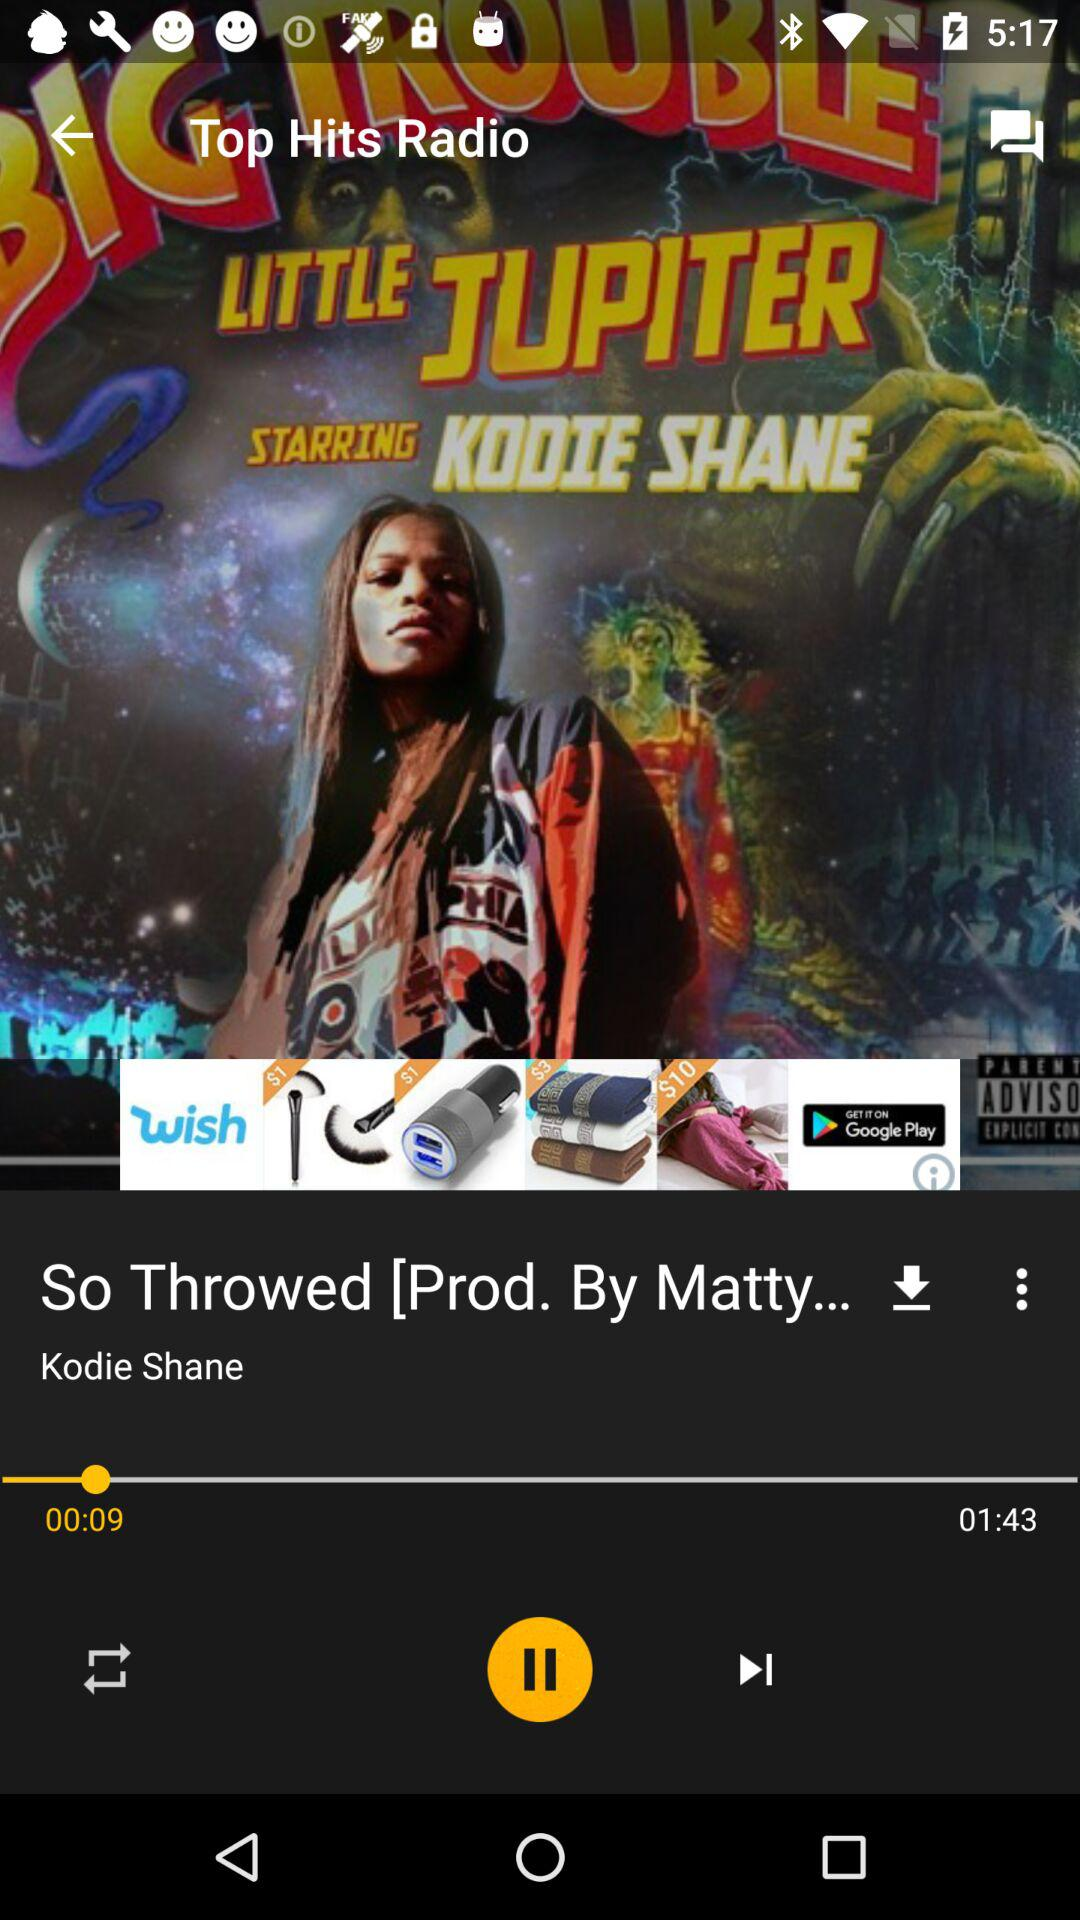How much of the song has elapsed? The elapsed duration of the song is 9 seconds. 